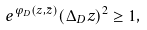Convert formula to latex. <formula><loc_0><loc_0><loc_500><loc_500>e ^ { \varphi _ { D } ( z , \bar { z } ) } ( \Delta _ { D } z ) ^ { 2 } \geq 1 ,</formula> 